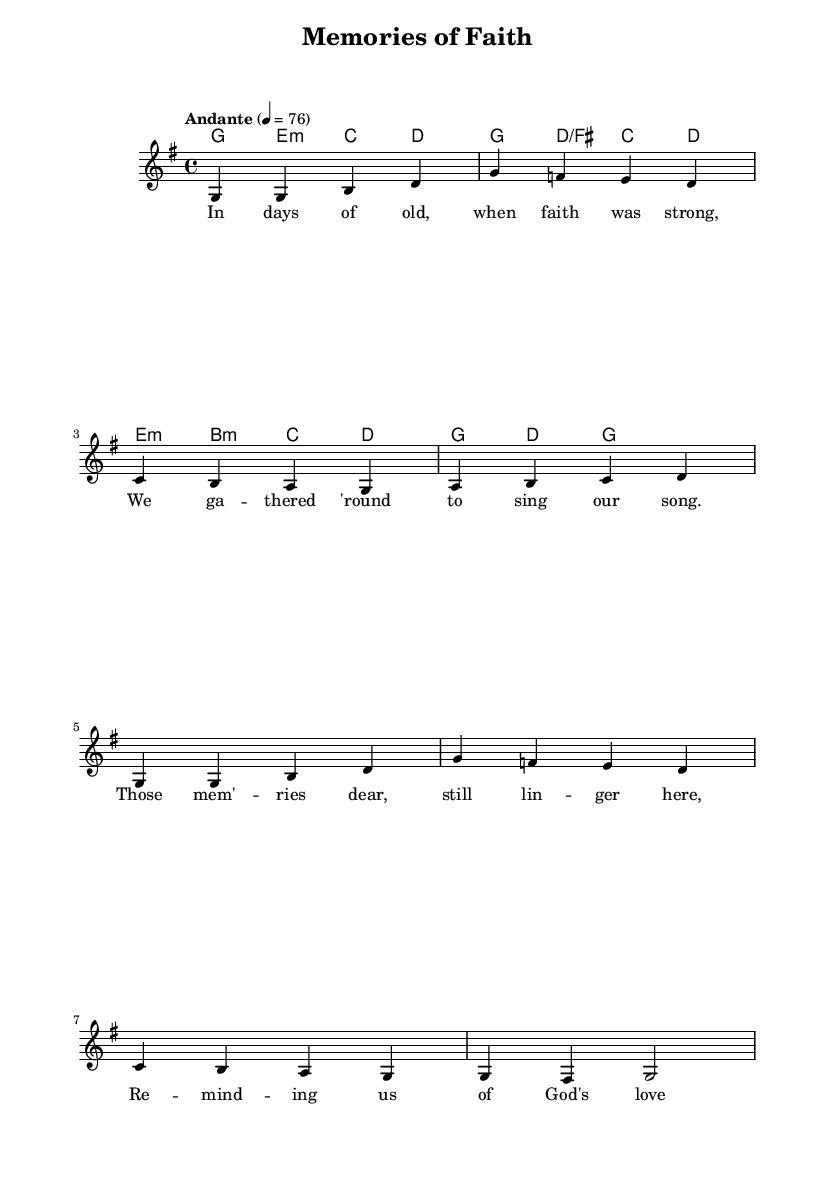What is the key signature of this music? The key signature is G major, which has one sharp (F#). You can determine this by looking at the initial clef and the sharp indicated at the beginning of the staff, which informs us that F is raised.
Answer: G major What is the time signature of this music? The time signature is 4/4. This can be found at the beginning of the score where it is indicated, signifying that there are four beats in a measure and the quarter note receives one beat.
Answer: 4/4 What is the tempo marking of this piece? The tempo marking is "Andante" at 76 beats per minute. This is written directly above the staff, indicating a moderate pace.
Answer: Andante How many measures are in the melody? The melody consists of 8 measures. You can count the vertical lines separating each measure in the music to arrive at this total.
Answer: 8 What is the predominant theme reflected in the lyrics? The predominant theme in the lyrics reflects nostalgia and faith. The lyrics mention memories of strong faith and God's love, emphasizing a connection to the past.
Answer: Nostalgia and faith Which chord is played in the last measure? The last measure contains the G major chord. This can be determined by looking at the harmonic notation in the final measure, which indicates G.
Answer: G major What is the significance of the lyrics "reminding us of God's love"? These lyrics convey the emotional connection and reassurance provided by faith, highlighting how memories can connect individuals to their spiritual beliefs and history.
Answer: Emotional connection to faith 